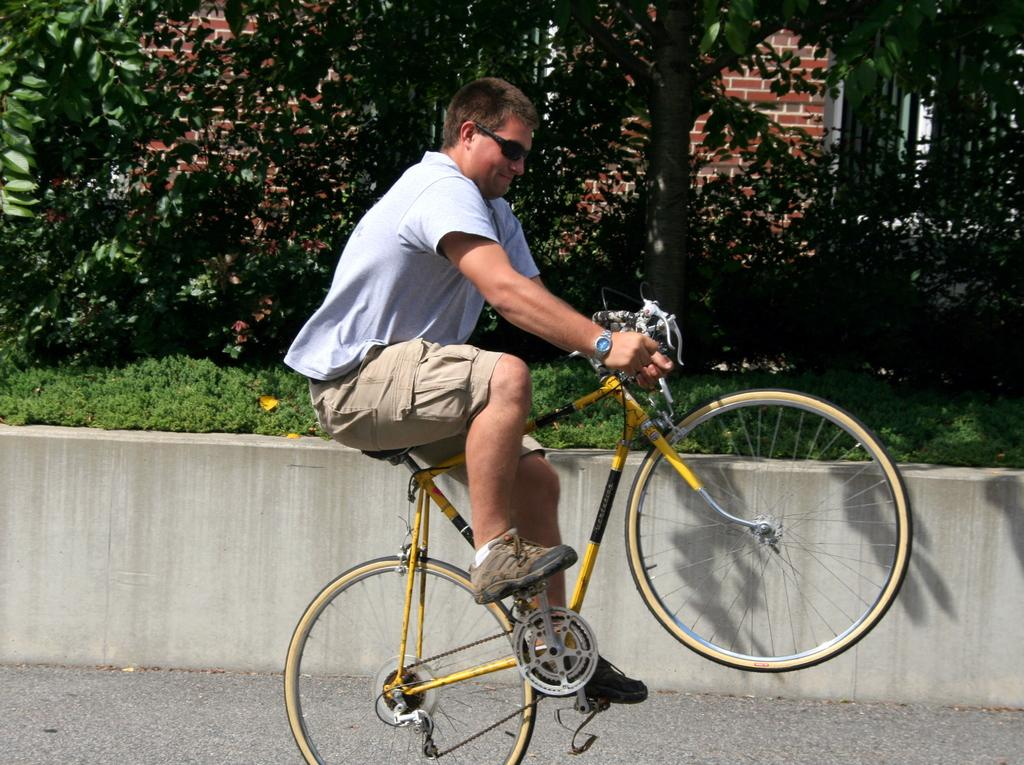Who or what is the main subject in the image? There is a person in the image. What is the person wearing? The person is wearing goggles. What activity is the person engaged in? The person is riding a bicycle. Where is the bicycle located? The bicycle is on the road. What can be seen to the left of the person? There are trees to the left of the person. What type of structure is visible in the image? There is a brick wall visible in the image. What type of form can be seen in the cemetery in the image? There is no cemetery or form present in the image; it features a person riding a bicycle on the road with trees and a brick wall visible. 